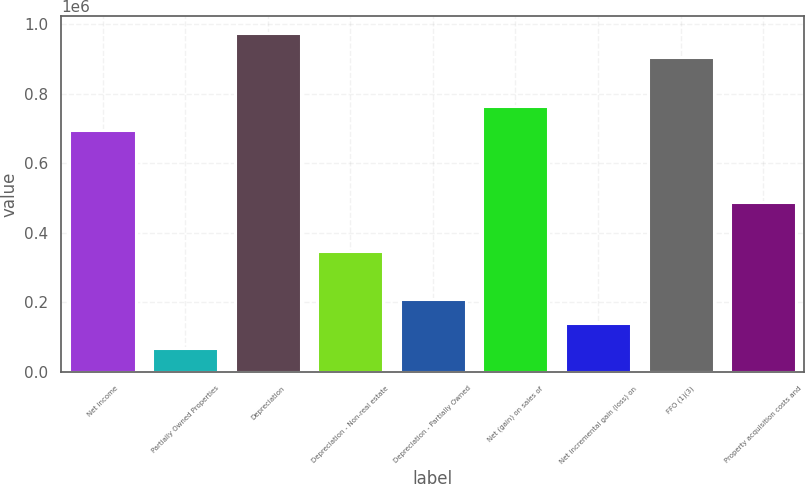Convert chart to OTSL. <chart><loc_0><loc_0><loc_500><loc_500><bar_chart><fcel>Net income<fcel>Partially Owned Properties<fcel>Depreciation<fcel>Depreciation - Non-real estate<fcel>Depreciation - Partially Owned<fcel>Net (gain) on sales of<fcel>Net incremental gain (loss) on<fcel>FFO (1)(3)<fcel>Property acquisition costs and<nl><fcel>696790<fcel>69751<fcel>975474<fcel>348435<fcel>209093<fcel>766461<fcel>139422<fcel>905803<fcel>487777<nl></chart> 